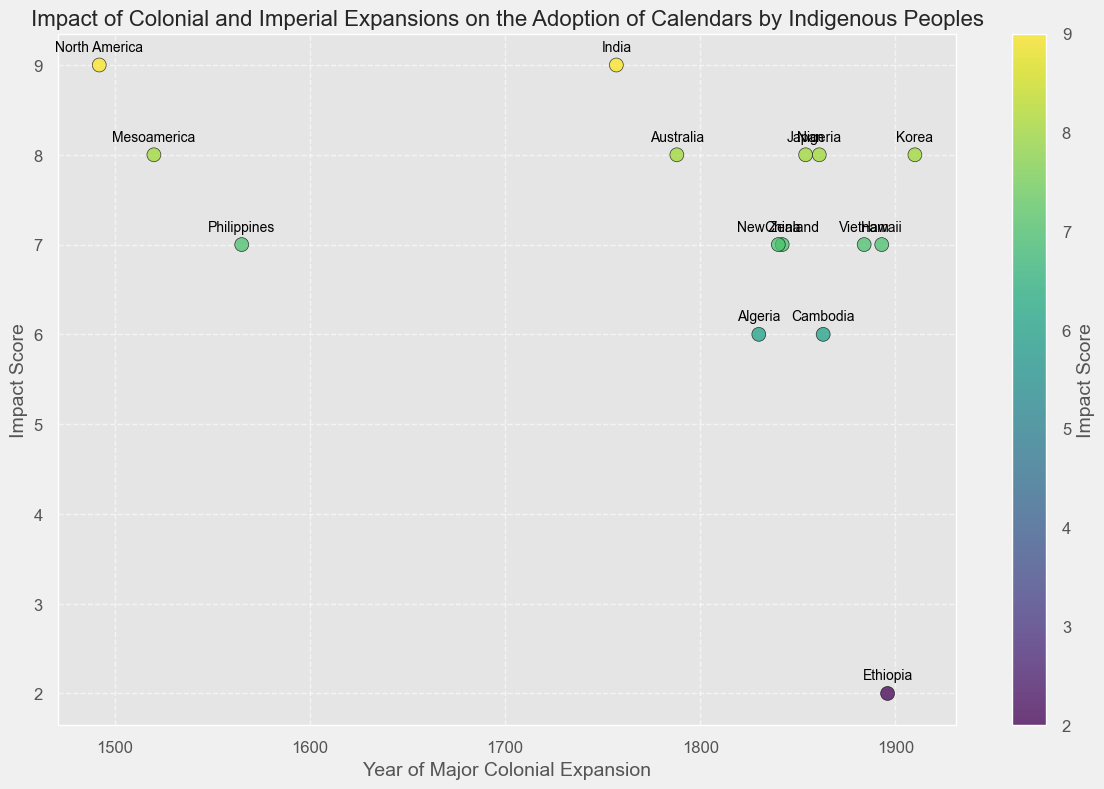Which region had the earliest colonial expansion? By looking at the scatter plot, find the point aligned furthest left along the x-axis, representing the earliest year.
Answer: North America Which two regions have the highest impact scores according to the plot? Identify the two points positioned at the highest y-axis values, which represent the highest impact scores.
Answer: North America and India Which region had a major colonial expansion in 1896, and what was the impact score? Locate the scatter point at the year 1896 along the x-axis, then read its corresponding y-axis value and label.
Answer: Ethiopia, 2 What is the difference in the impact score between the earliest colonial expansion and the latest one? Identify the impact scores for the regions with the earliest (North America, 1492) and latest (Korea, 1910) colonial expansions and subtract the earlier score from the later one (9 - 8).
Answer: 1 Which region experienced major colonial expansion in 1842, and what was its impact score and the adopted calendar system? Locate the point on the plot for the year 1842 and read the corresponding impact score and region label, then refer to the provided data for the adopted calendar system.
Answer: China, 7, Gregorian What is the average impact score for colonial expansions that occurred before 1800? Identify points left of the x-axis year's midpoint at 1800, then average their y-axis values: (8 + 7 + 7 + 9 + 8 + 7 + 8 + 7) / 8 = 61 / 8.
Answer: 7.625 Which region transitioned from the Ethiopian Calendar system? Locate the annotated region corresponding to the Ethiopian calendar, typically slightly above and to the left of its scatter point.
Answer: Ethiopia How many regions have an impact score of 7? Count all the points in the plot aligned horizontally with the y-axis value of 7.
Answer: 5 Between Japan and Nigeria, which region had a higher impact score, and by how much? Compare the y-axis positions for Japan and Nigeria and find the difference (8 - 8 = 0). They have the same impact score.
Answer: Both have the same impact score Which two regions adopted the Gregorian calendar system around the 1880s and 1890s? Identify scatter points between the years 1880s and 1890s and determine their corresponding regions.
Answer: Ethiopia and Hawaii 